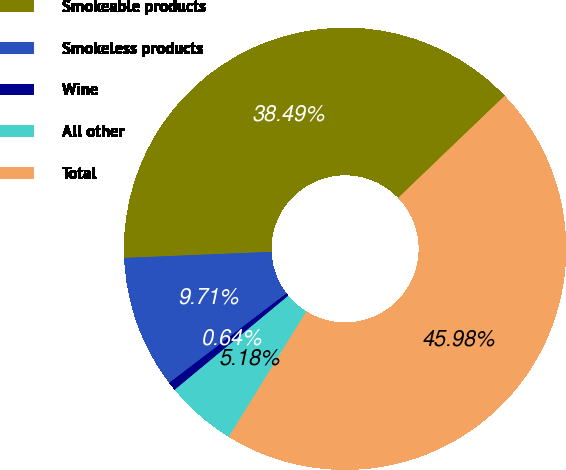Convert chart to OTSL. <chart><loc_0><loc_0><loc_500><loc_500><pie_chart><fcel>Smokeable products<fcel>Smokeless products<fcel>Wine<fcel>All other<fcel>Total<nl><fcel>38.49%<fcel>9.71%<fcel>0.64%<fcel>5.18%<fcel>45.98%<nl></chart> 